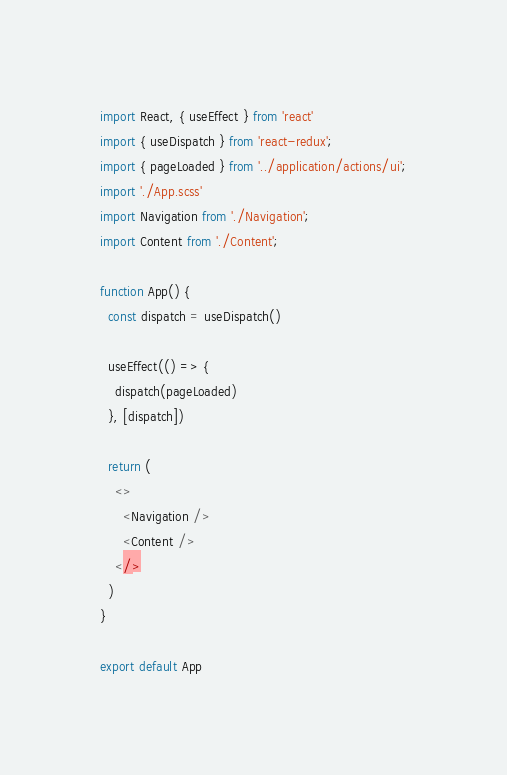<code> <loc_0><loc_0><loc_500><loc_500><_TypeScript_>import React, { useEffect } from 'react'
import { useDispatch } from 'react-redux';
import { pageLoaded } from '../application/actions/ui';
import './App.scss'
import Navigation from './Navigation';
import Content from './Content';

function App() {
  const dispatch = useDispatch()

  useEffect(() => {
    dispatch(pageLoaded)
  }, [dispatch])

  return (
    <>
      <Navigation />
      <Content />
    </>
  )
}

export default App</code> 